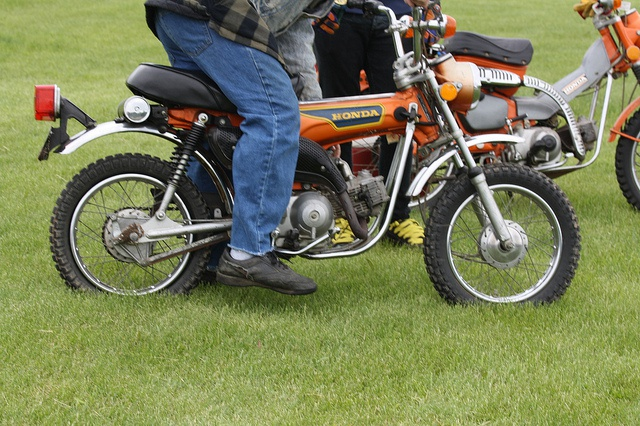Describe the objects in this image and their specific colors. I can see motorcycle in olive, black, gray, and lightgray tones, people in olive, gray, black, and blue tones, motorcycle in olive, darkgray, black, and gray tones, and people in olive, black, gray, navy, and khaki tones in this image. 